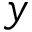<formula> <loc_0><loc_0><loc_500><loc_500>y</formula> 